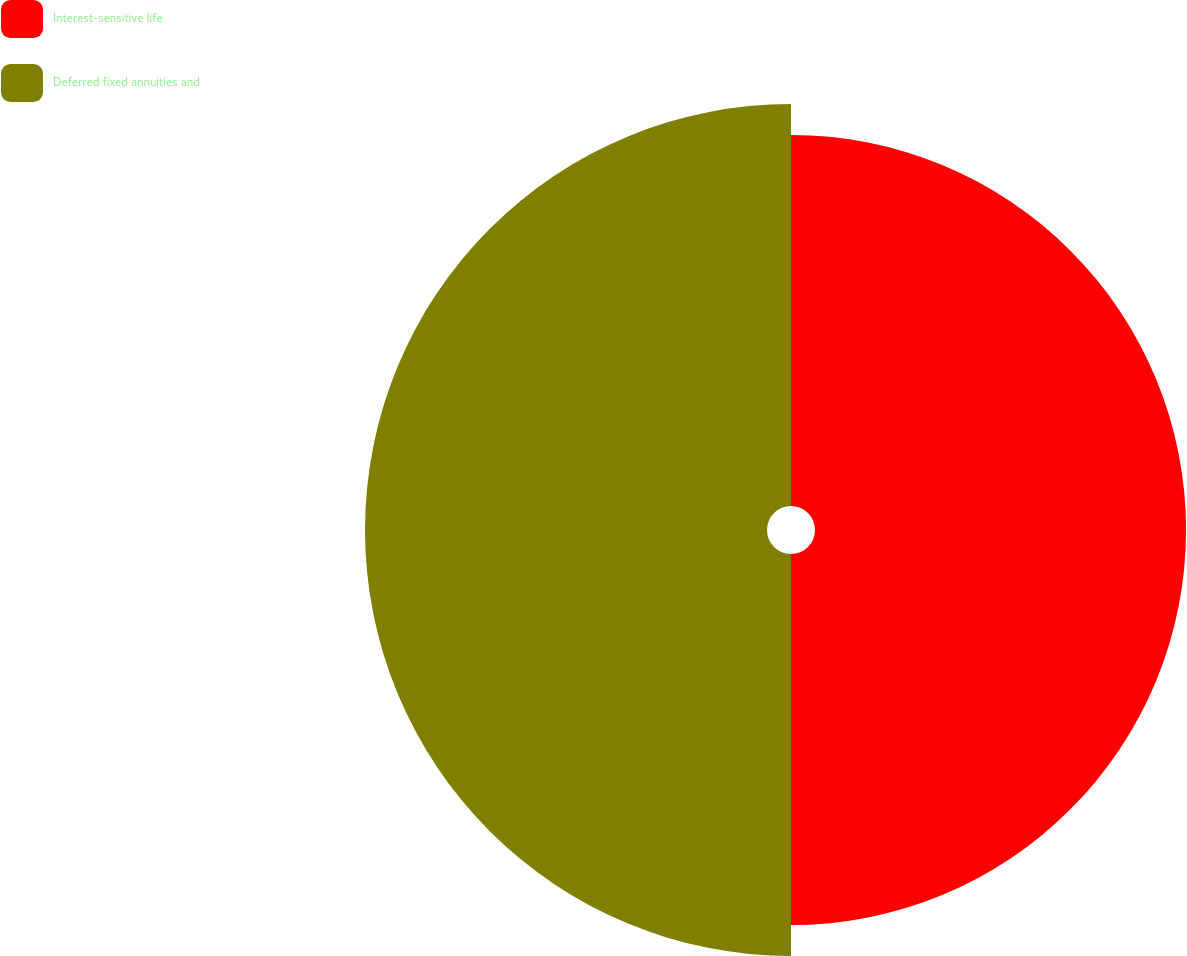Convert chart. <chart><loc_0><loc_0><loc_500><loc_500><pie_chart><fcel>Interest-sensitive life<fcel>Deferred fixed annuities and<nl><fcel>48.0%<fcel>52.0%<nl></chart> 